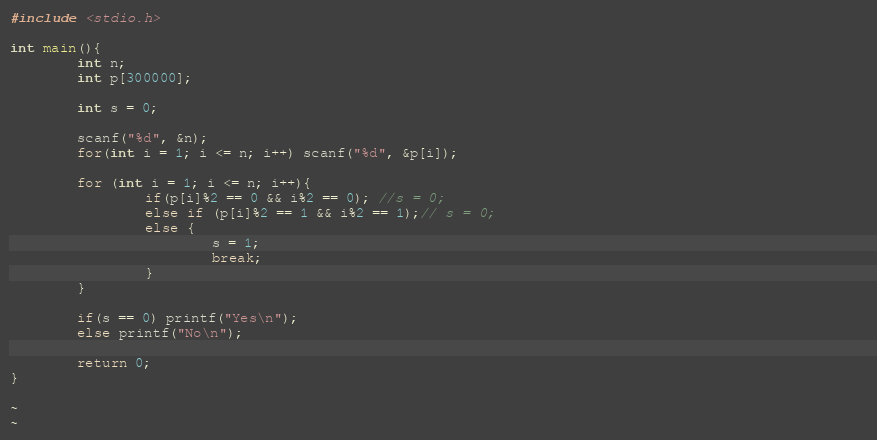Convert code to text. <code><loc_0><loc_0><loc_500><loc_500><_C_>#include <stdio.h>

int main(){
        int n;
        int p[300000];

        int s = 0;

        scanf("%d", &n);
        for(int i = 1; i <= n; i++) scanf("%d", &p[i]);

        for (int i = 1; i <= n; i++){
                if(p[i]%2 == 0 && i%2 == 0); //s = 0;
                else if (p[i]%2 == 1 && i%2 == 1);// s = 0;
                else {
                        s = 1;
                        break;
                }
        }

        if(s == 0) printf("Yes\n");
        else printf("No\n");

        return 0;
}

~                                                                                                     
~                 </code> 